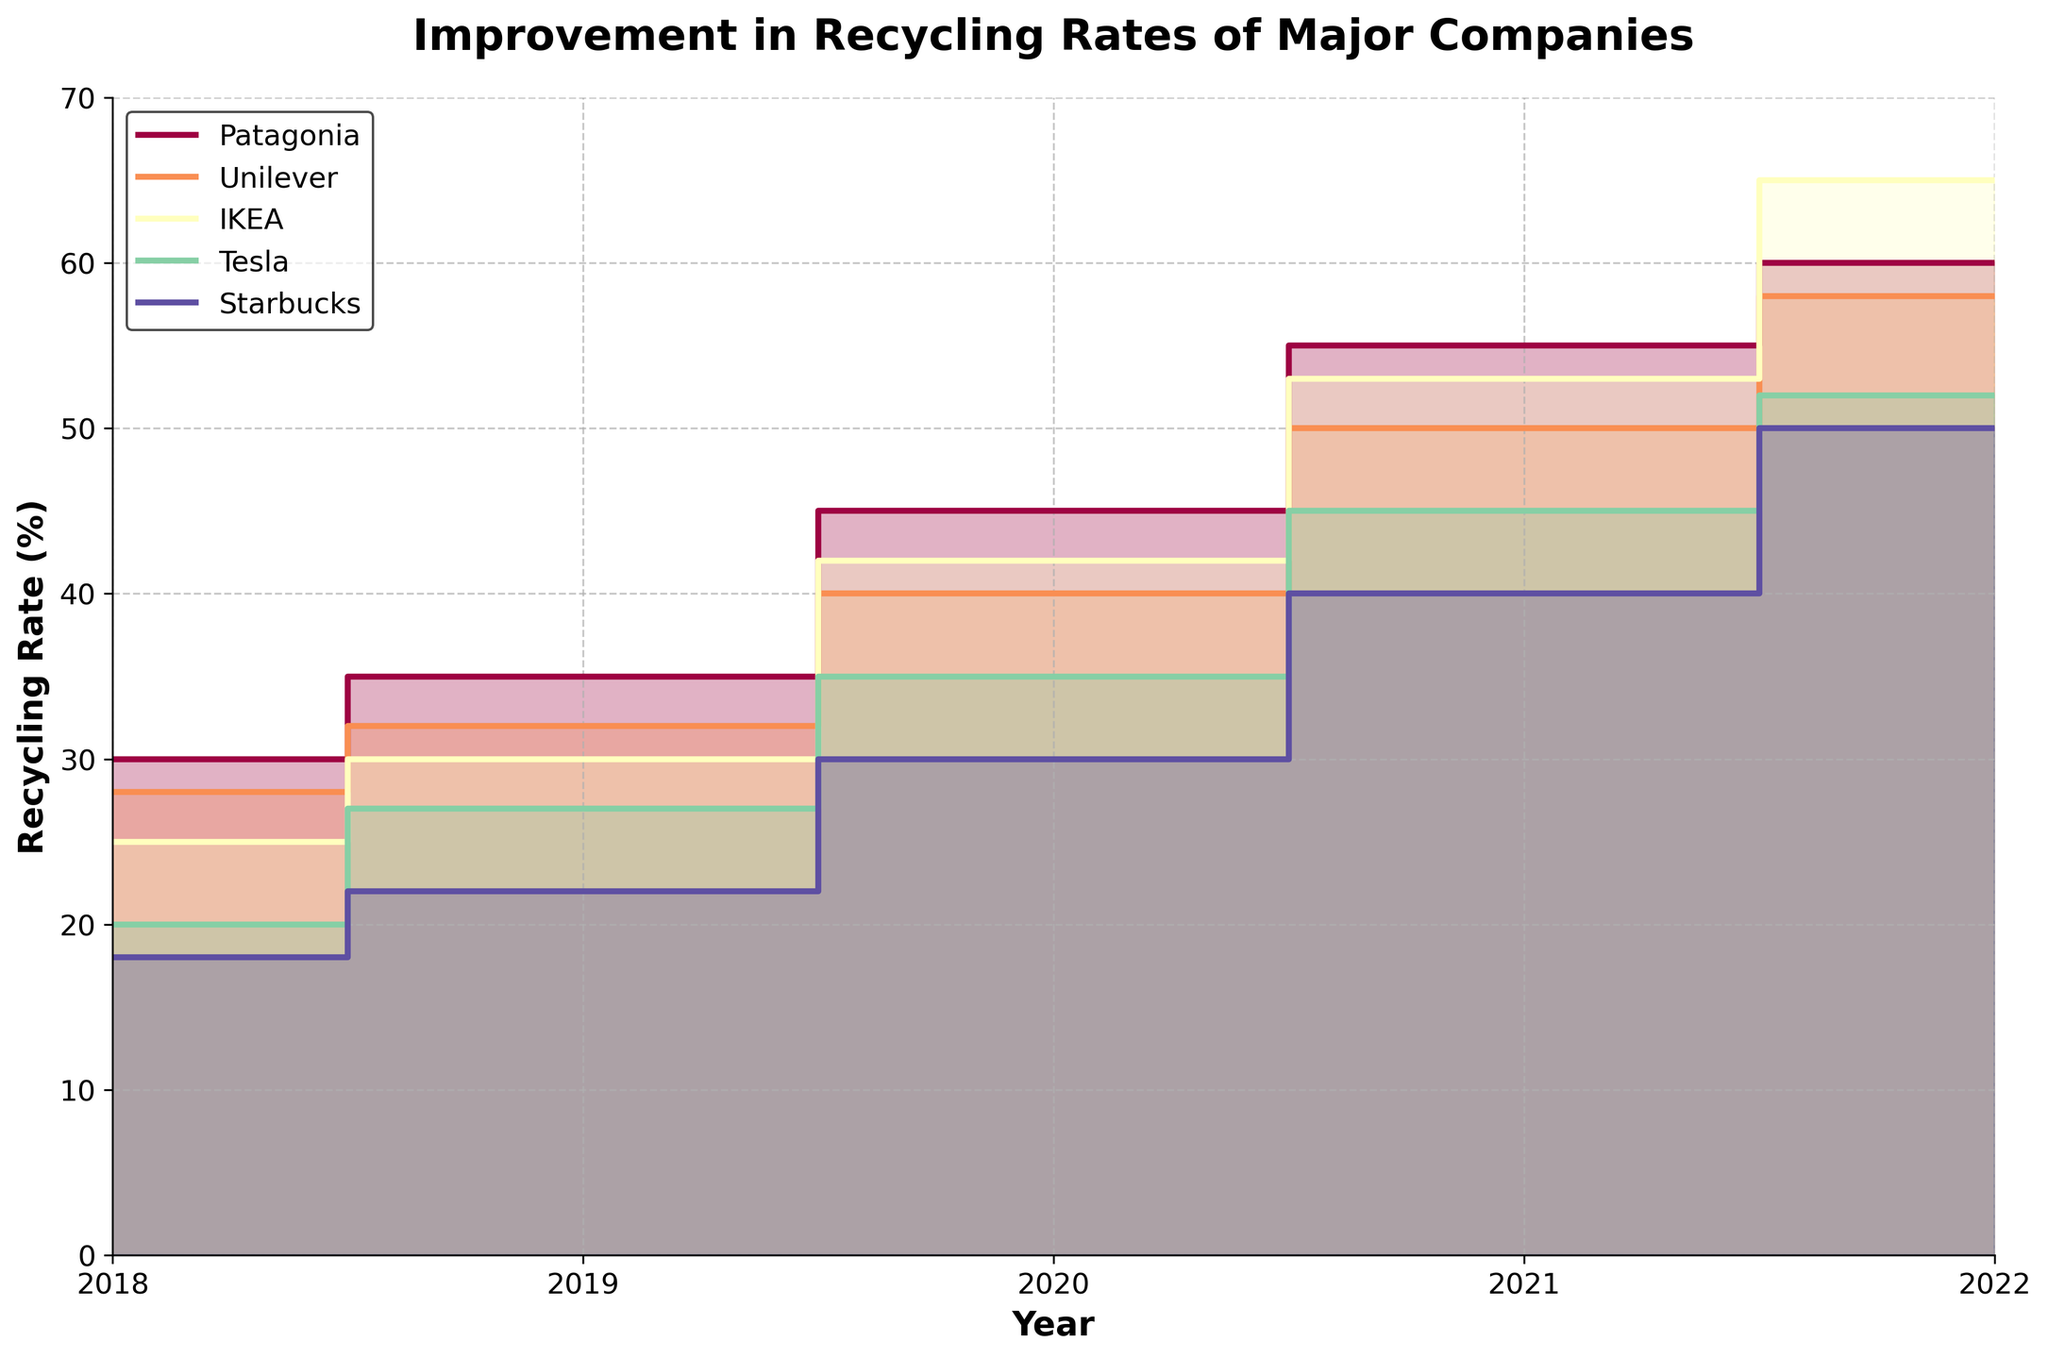What is the title of the figure? The title of the figure is usually placed at the top and can be identified easily.
Answer: Improvement in Recycling Rates of Major Companies What are the years covered in the figure? The years are typically shown on the x-axis. In this figure, the x-axis labels show the range of years.
Answer: 2018 to 2022 Which company had the highest recycling rate in 2022? By looking at the values in 2022 on the y-axis and comparing the recycling rates among the companies, IKEA had the highest recycling rate.
Answer: IKEA How does Unilever's recycling rate in 2021 compare to Patagonia's recycling rate in the same year? To compare these two, find the recycling rates for both companies in the year 2021. Patagonia's rate was 55%, and Unilever's was 50%.
Answer: Patagonia's rate is higher What is the overall trend for Tesla's recycling rate from 2018 to 2022? Observe the recycling rates for Tesla from 2018 to 2022: the values go from 20% in 2018 to 52% in 2022, indicating a consistent upward trend.
Answer: Increasing Which company had the largest increase in recycling rate from 2019 to 2020? Calculate the change for each company between these years. Patagonia: 45%-35%=10%, Unilever: 40%-32%=8%, IKEA: 42%-30%=12%, Tesla: 35%-27%=8%, Starbucks: 30%-22%=8%. IKEA shows the largest increase of 12%.
Answer: IKEA How do the recycling rates of Starbucks and Patagonia compare in 2018 and what could this indicate? Compare the 2018 recycling rates: Starbucks at 18% and Patagonia at 30%. This indicates that in 2018, Patagonia had a much higher focus on recycling compared to Starbucks.
Answer: Patagonia's rate is higher Between which consecutive years did IKEA show the biggest improvement in recycling rates? Check increases year by year for IKEA. 2018-2019: 5%, 2019-2020: 12%, 2020-2021: 11%, 2021-2022: 12%. Both 2019-2020 and 2021-2022 show the highest increases at 12%.
Answer: 2019-2020 and 2021-2022 What is the difference in recycling rate between Tesla and Unilever in 2019? Find and subtract the rates: Tesla (27%) and Unilever (32%). 32% - 27% = 5%.
Answer: 5% What is the average recycling rate for Patagonia from 2018 to 2022? Add the rates for Patagonia across these years and divide by the number of years: (30% + 35% + 45% + 55% + 60%) / 5 = 45%.
Answer: 45% 